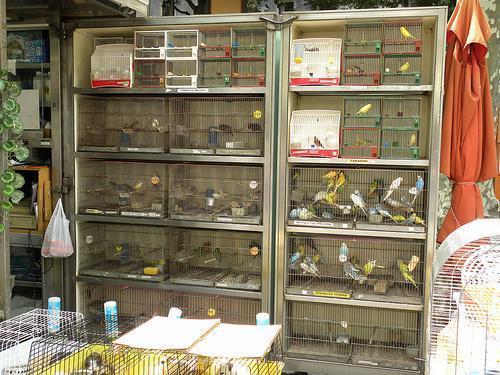How many shelves have birdcages on them?
Give a very brief answer. 10. How many yellow birds are in this picture?
Give a very brief answer. 11. 